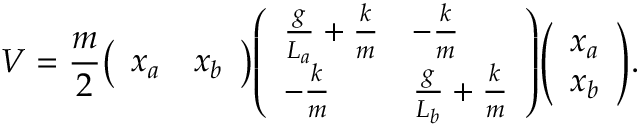<formula> <loc_0><loc_0><loc_500><loc_500>V = { \frac { m } { 2 } } { \left ( \begin{array} { l l } { x _ { a } } & { x _ { b } } \end{array} \right ) } { \left ( \begin{array} { l l } { { \frac { g } { L _ { a } } } + { \frac { k } { m } } } & { - { \frac { k } { m } } } \\ { - { \frac { k } { m } } } & { { \frac { g } { L _ { b } } } + { \frac { k } { m } } } \end{array} \right ) } { \left ( \begin{array} { l } { x _ { a } } \\ { x _ { b } } \end{array} \right ) } .</formula> 